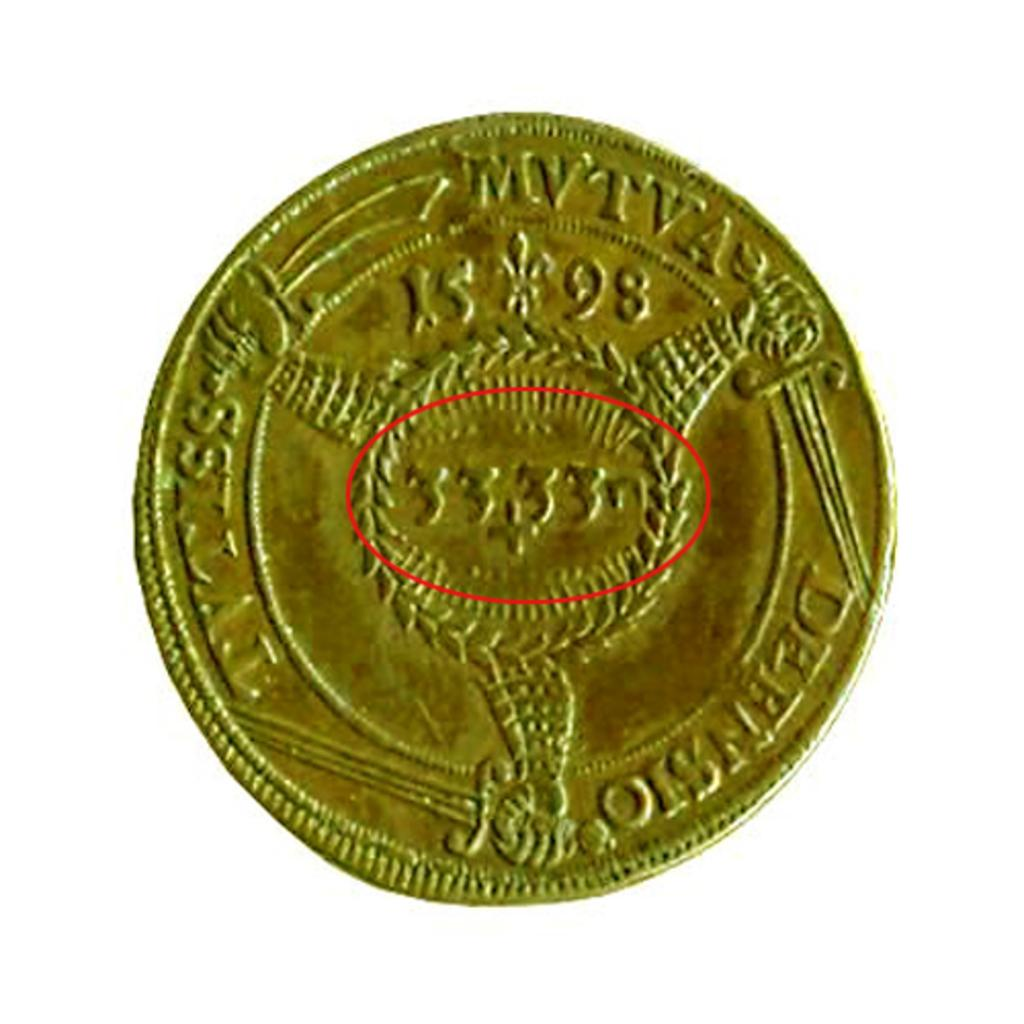<image>
Write a terse but informative summary of the picture. A gold colored coin from the year 1598. 